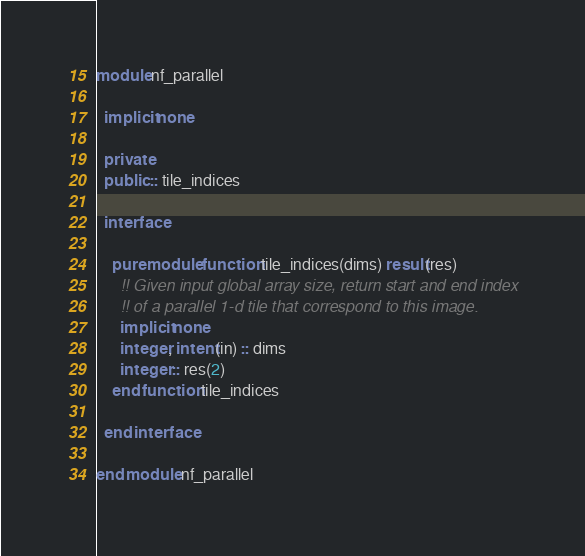Convert code to text. <code><loc_0><loc_0><loc_500><loc_500><_FORTRAN_>module nf_parallel

  implicit none

  private
  public :: tile_indices

  interface
  
    pure module function tile_indices(dims) result(res)
      !! Given input global array size, return start and end index
      !! of a parallel 1-d tile that correspond to this image.
      implicit none
      integer, intent(in) :: dims
      integer :: res(2)
    end function tile_indices
  
  end interface

end module nf_parallel
</code> 